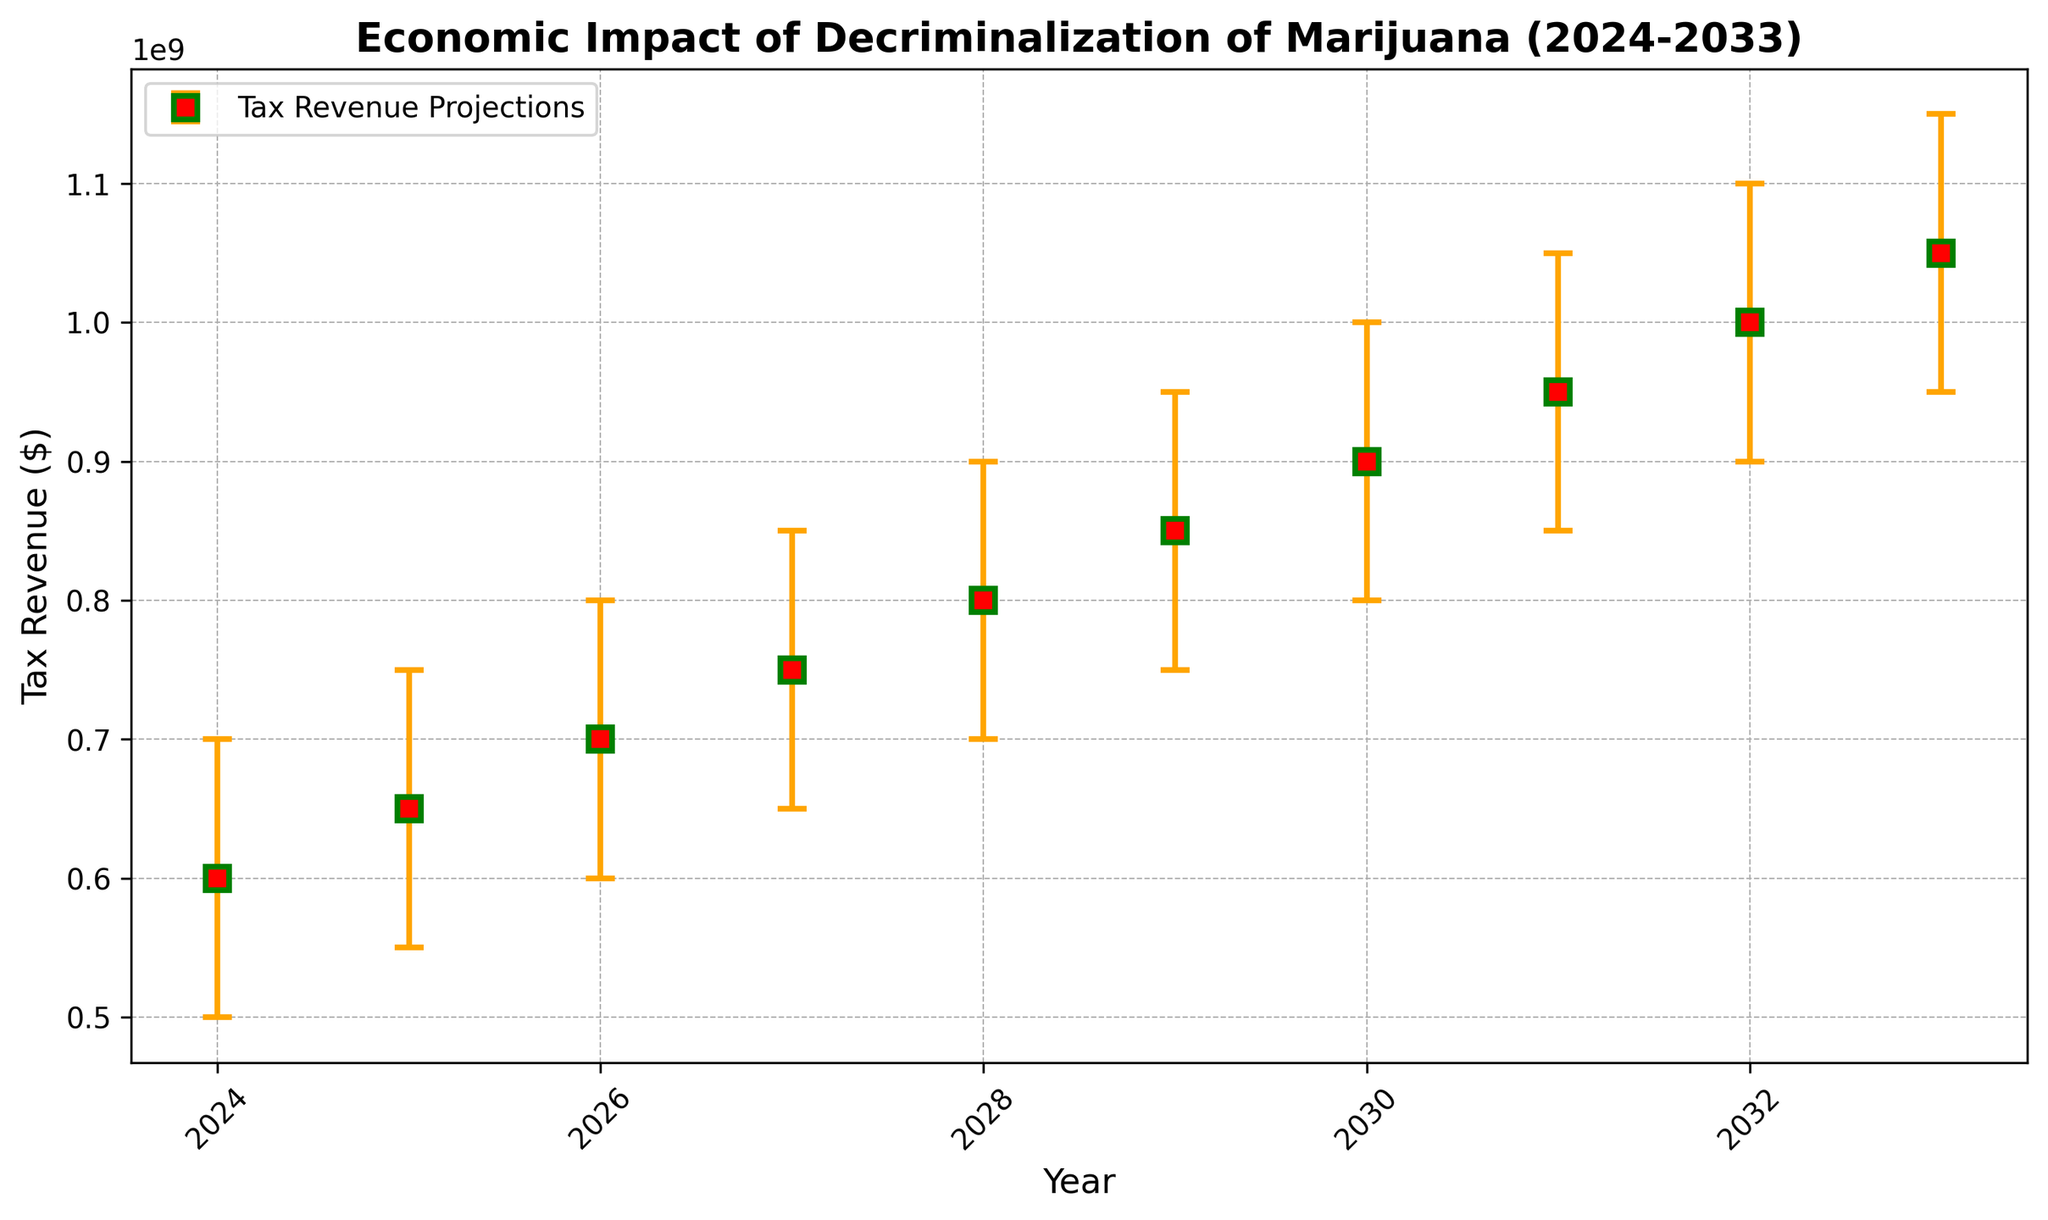What is the mean tax revenue projection for 2025? We need to look at the figure and find the mean estimate for the year 2025. This is indicated by one of the markers. According to the figure, the mean estimate for 2025 is $650,000,000.
Answer: $650,000,000 Which year shows the highest mean estimate for tax revenue? To find this, we look at the mean estimates for all the years plotted. The highest mean estimate is at the end of the time series in 2033, which is $1,050,000,000.
Answer: 2033 By how much does the mean estimate increase from 2024 to 2026? The mean estimate for 2024 is $600,000,000 and for 2026 is $700,000,000. The difference between these values is $700,000,000 - $600,000,000 = $100,000,000.
Answer: $100,000,000 In which year is the uncertainty (error bar) the largest? The uncertainty is the range represented by the error bars. The length of the error bars grows each year, so the largest uncertainty is in 2033, where the error bar spans from $950,000,000 to $1,150,000,000.
Answer: 2033 What is the difference between the highest and lowest tax revenue estimates for 2030? The low estimate for 2030 is $800,000,000 and the high estimate is $1,000,000,000. The difference is $1,000,000,000 - $800,000,000 = $200,000,000.
Answer: $200,000,000 How do the mean estimates for 2027 and 2028 compare? From the figure, the mean estimates for 2027 is $750,000,000 and for 2028 is $800,000,000. The mean estimate for 2028 is higher than for 2027.
Answer: 2028 is higher What is the trend in mean tax revenue estimates from 2024 to 2033? Observing the mean estimates plotted on the figure, they show a steady linear increase each year from 2024 ($600,000,000) to 2033 ($1,050,000,000).
Answer: Increasing In which years do the upper and lower bounds of the tax revenue projections overlap the least? The error bars visually get wider over the years, so the beginning years such as 2024 have the smallest spread with bounds from $500,000,000 to $700,000,000.
Answer: 2024 What is the mean estimate for 2030, and how does it compare to the mean estimate for 2025? The mean estimate for 2030 is $900,000,000 and for 2025 is $650,000,000. The mean estimate for 2030 is higher by $250,000,000.
Answer: $900,000,000; $250,000,000 higher 